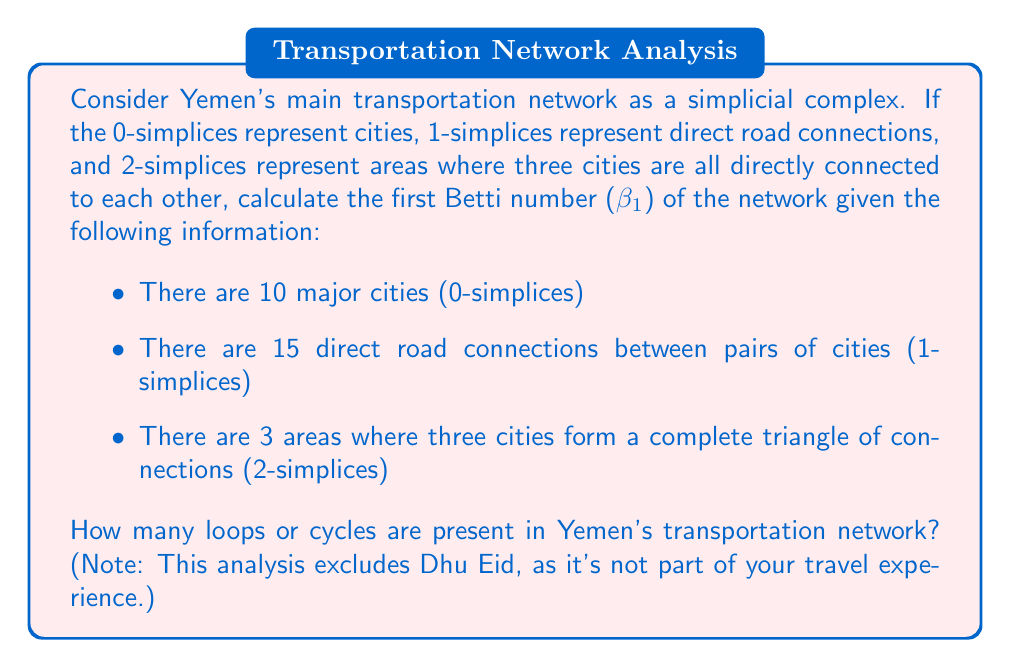Teach me how to tackle this problem. To solve this problem, we'll use the concepts of algebraic topology, specifically the calculation of Betti numbers. The first Betti number ($\beta_1$) represents the number of 1-dimensional holes or loops in the simplicial complex, which in this case corresponds to cycles in the transportation network.

Let's follow these steps:

1) First, we need to calculate the Euler characteristic ($\chi$) of the simplicial complex:
   
   $\chi = n_0 - n_1 + n_2$
   
   Where:
   $n_0$ = number of 0-simplices (cities) = 10
   $n_1$ = number of 1-simplices (road connections) = 15
   $n_2$ = number of 2-simplices (triangular connections) = 3

   $\chi = 10 - 15 + 3 = -2$

2) The Euler characteristic is related to the Betti numbers by the formula:
   
   $\chi = \beta_0 - \beta_1 + \beta_2$

3) In this case:
   $\beta_0$ = 1 (assuming the network is connected)
   $\beta_2$ = 0 (as we're only interested in 1-dimensional loops)

4) Substituting into the equation:
   
   $-2 = 1 - \beta_1 + 0$

5) Solving for $\beta_1$:
   
   $\beta_1 = 1 - (-2) = 3$

Therefore, the first Betti number of Yemen's transportation network is 3, indicating the presence of 3 loops or cycles in the network.
Answer: The first Betti number ($\beta_1$) of Yemen's transportation network is 3, meaning there are 3 loops or cycles present in the network. 